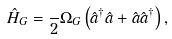Convert formula to latex. <formula><loc_0><loc_0><loc_500><loc_500>\hat { H } _ { G } = \frac { } { 2 } \Omega _ { G } \left ( \hat { a } ^ { \dagger } \hat { a } + \hat { a } \hat { a } ^ { \dagger } \right ) ,</formula> 